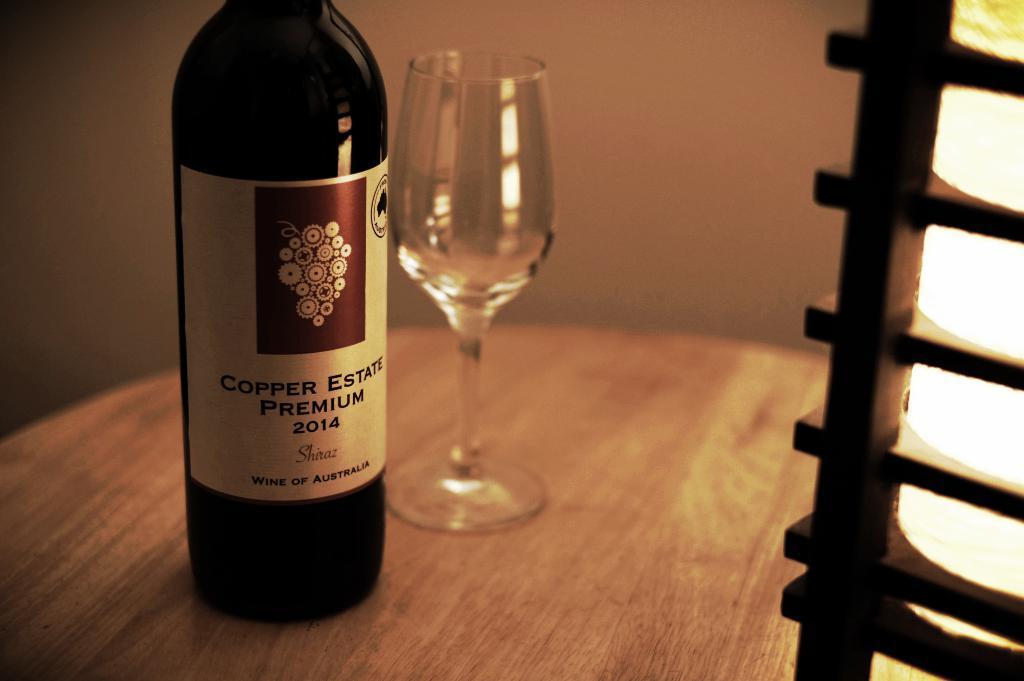In one or two sentences, can you explain what this image depicts? In this image there is a bottle and a glass on the table, there is a wooden wall and some lighting. 